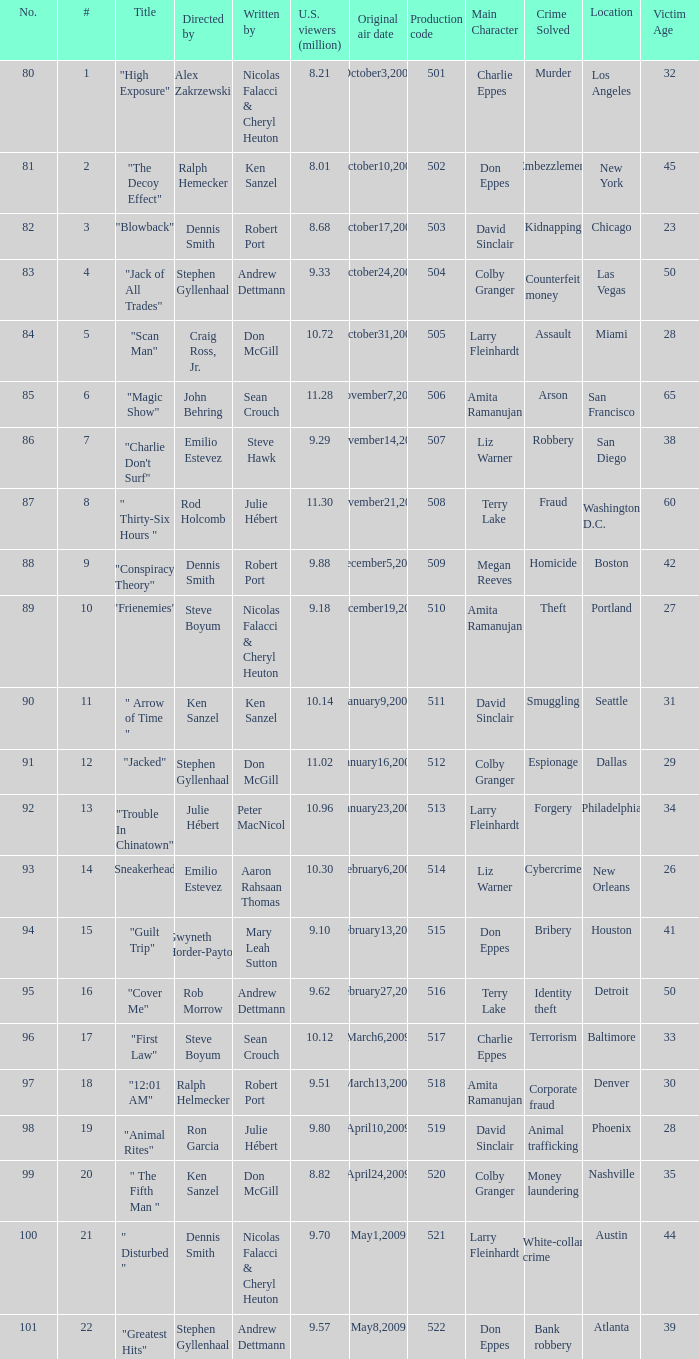Which episode's production code corresponds to the one with 9.18 million u.s. viewers? 510.0. 